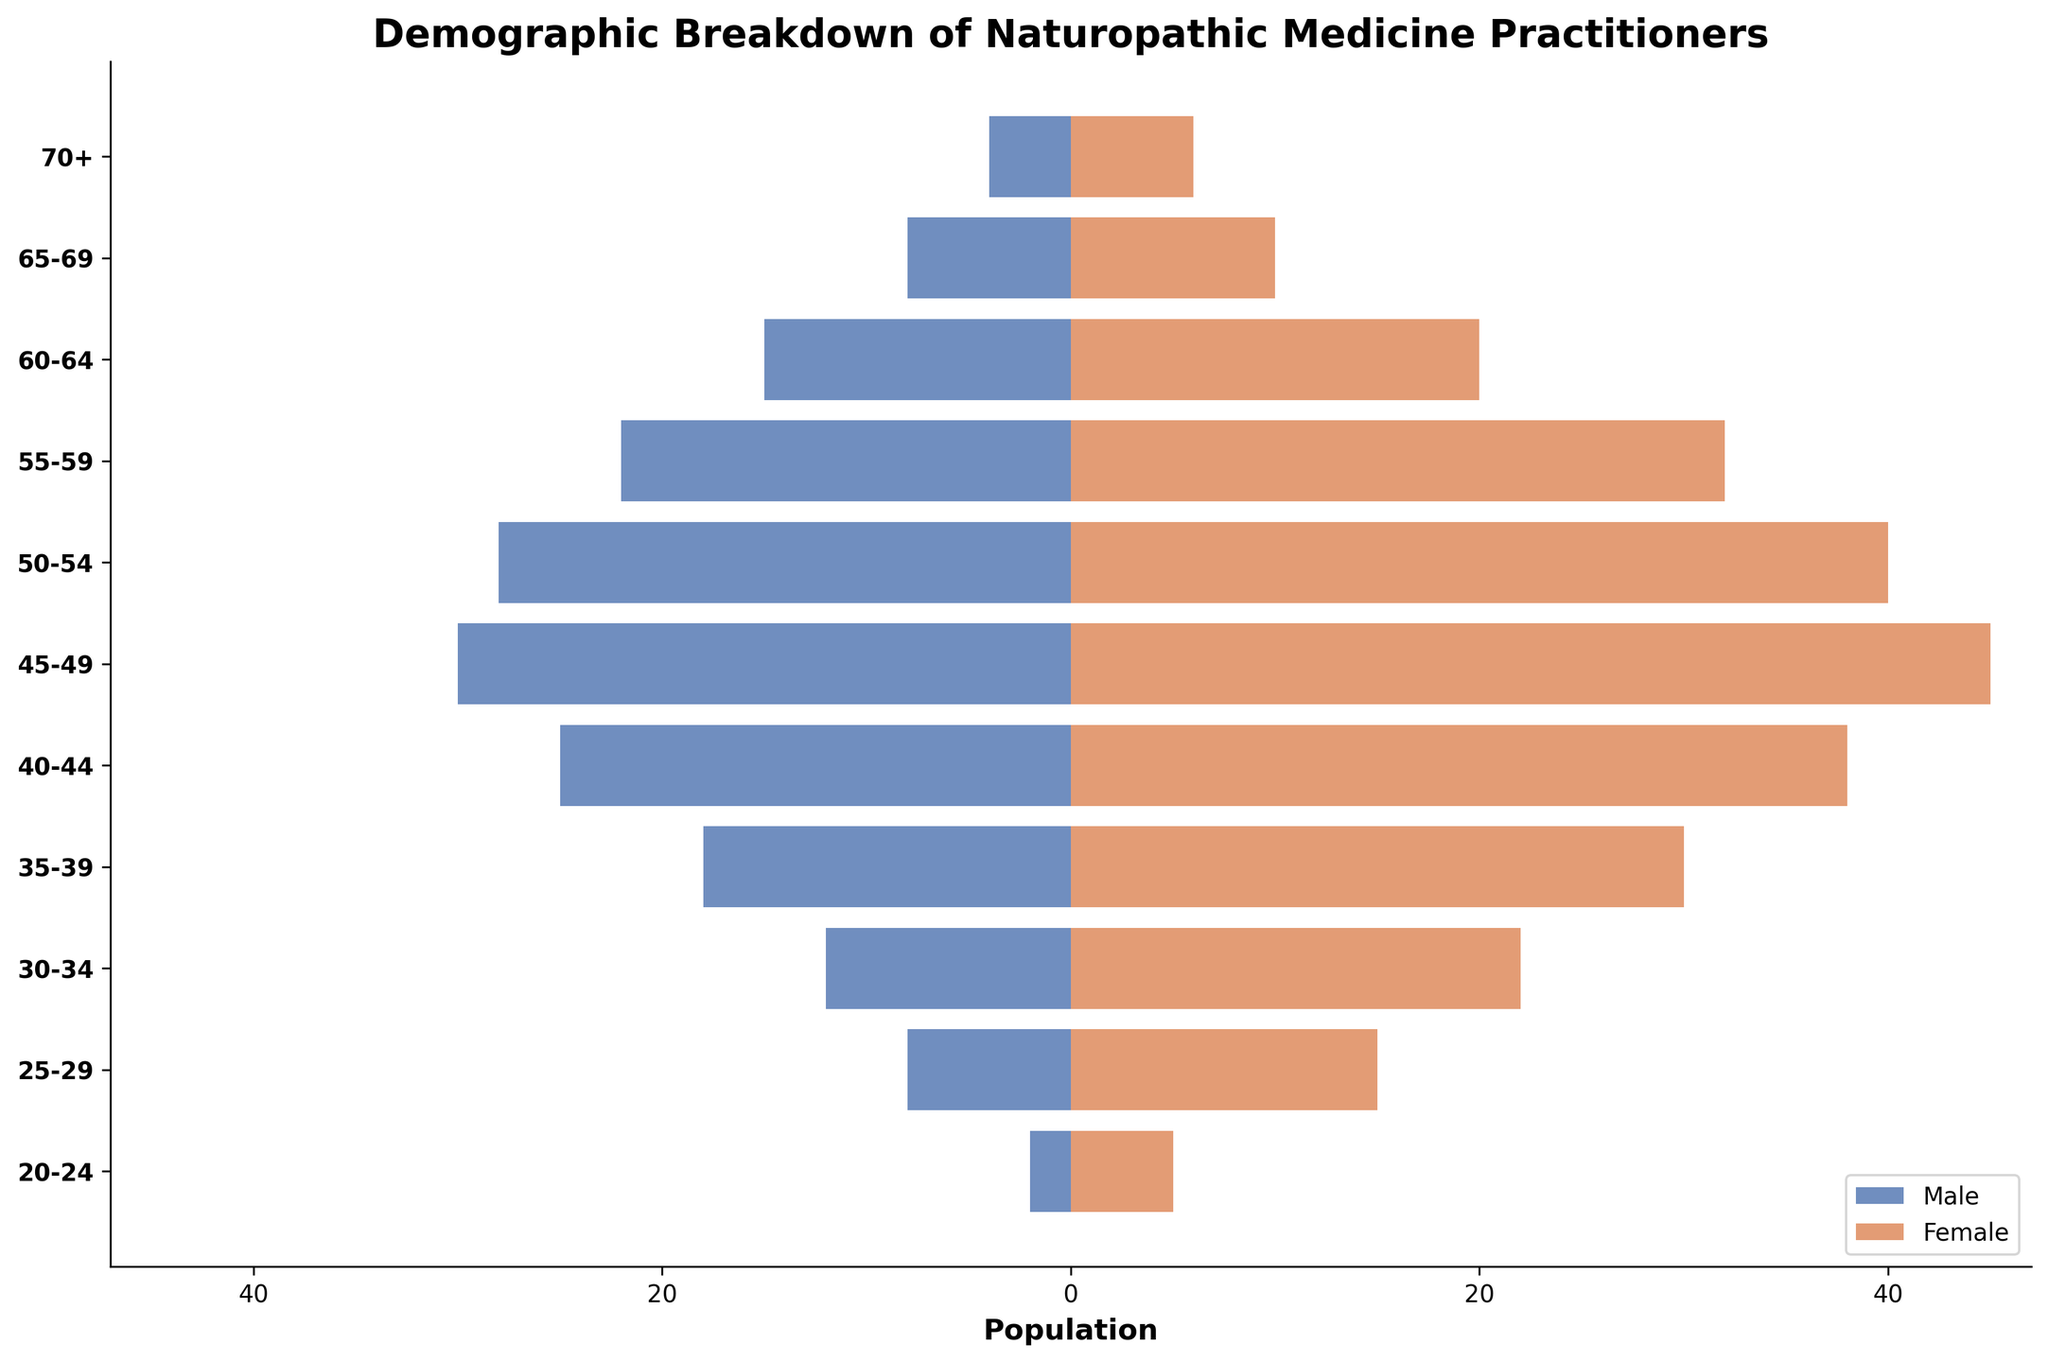What's the title of the figure? The title of the figure is typically located at the top center. When observing the figure, the title "Demographic Breakdown of Naturopathic Medicine Practitioners" is clearly indicated.
Answer: Demographic Breakdown of Naturopathic Medicine Practitioners What are the colors used to represent males and females? The figure uses different colors for males and females to make it easy to distinguish between them. Males are represented by a dark blue color, and females are shown in an orange color.
Answer: Blue for males, Orange for females Which age group has the largest population of male practitioners? To identify the age group with the largest population of male practitioners, we look for the longest bar in the male section. Specifically, the 45-49 age group has the largest male population with 30 practitioners.
Answer: 45-49 What is the combined population of male and female practitioners in the 60-64 age group? To find the combined population, add the number of male practitioners (15) and female practitioners (20) in the 60-64 age group. 15 males + 20 females = 35 practitioners.
Answer: 35 How does the population of female practitioners in the 50-54 age group compare to the male practitioners in the same age group? The bar lengths in the 50-54 age group can be compared to determine the difference. The female population is 40, while the male population is 28. Therefore, there are 12 more female practitioners than males.
Answer: Females outnumber males by 12 What is the population difference between the oldest age group (70+) and the youngest age group (20-24) for female practitioners? For the 70+ age group, there are 6 female practitioners, and for the 20-24 age group, there are 5 female practitioners. 6 - 5 = 1
Answer: 1 In which age group do we see the smallest population of male practitioners? By examining the shortest bars in the male section, we can see that the smallest population of male practitioners is in the 20-24 age group with 2 males.
Answer: 20-24 What is the total number of female practitioners in all age groups combined? Sum the number of female practitioners across all age groups: 5 + 15 + 22 + 30 + 38 + 45 + 40 + 32 + 20 + 10 + 6 which equals 263.
Answer: 263 Which age group shows a parity between male and female practitioners, if any? By comparing the lengths of the bars across all age groups for both genders, the age group 65-69 has the closest number of male (8) and female (10) practitioners.
Answer: 65-69 